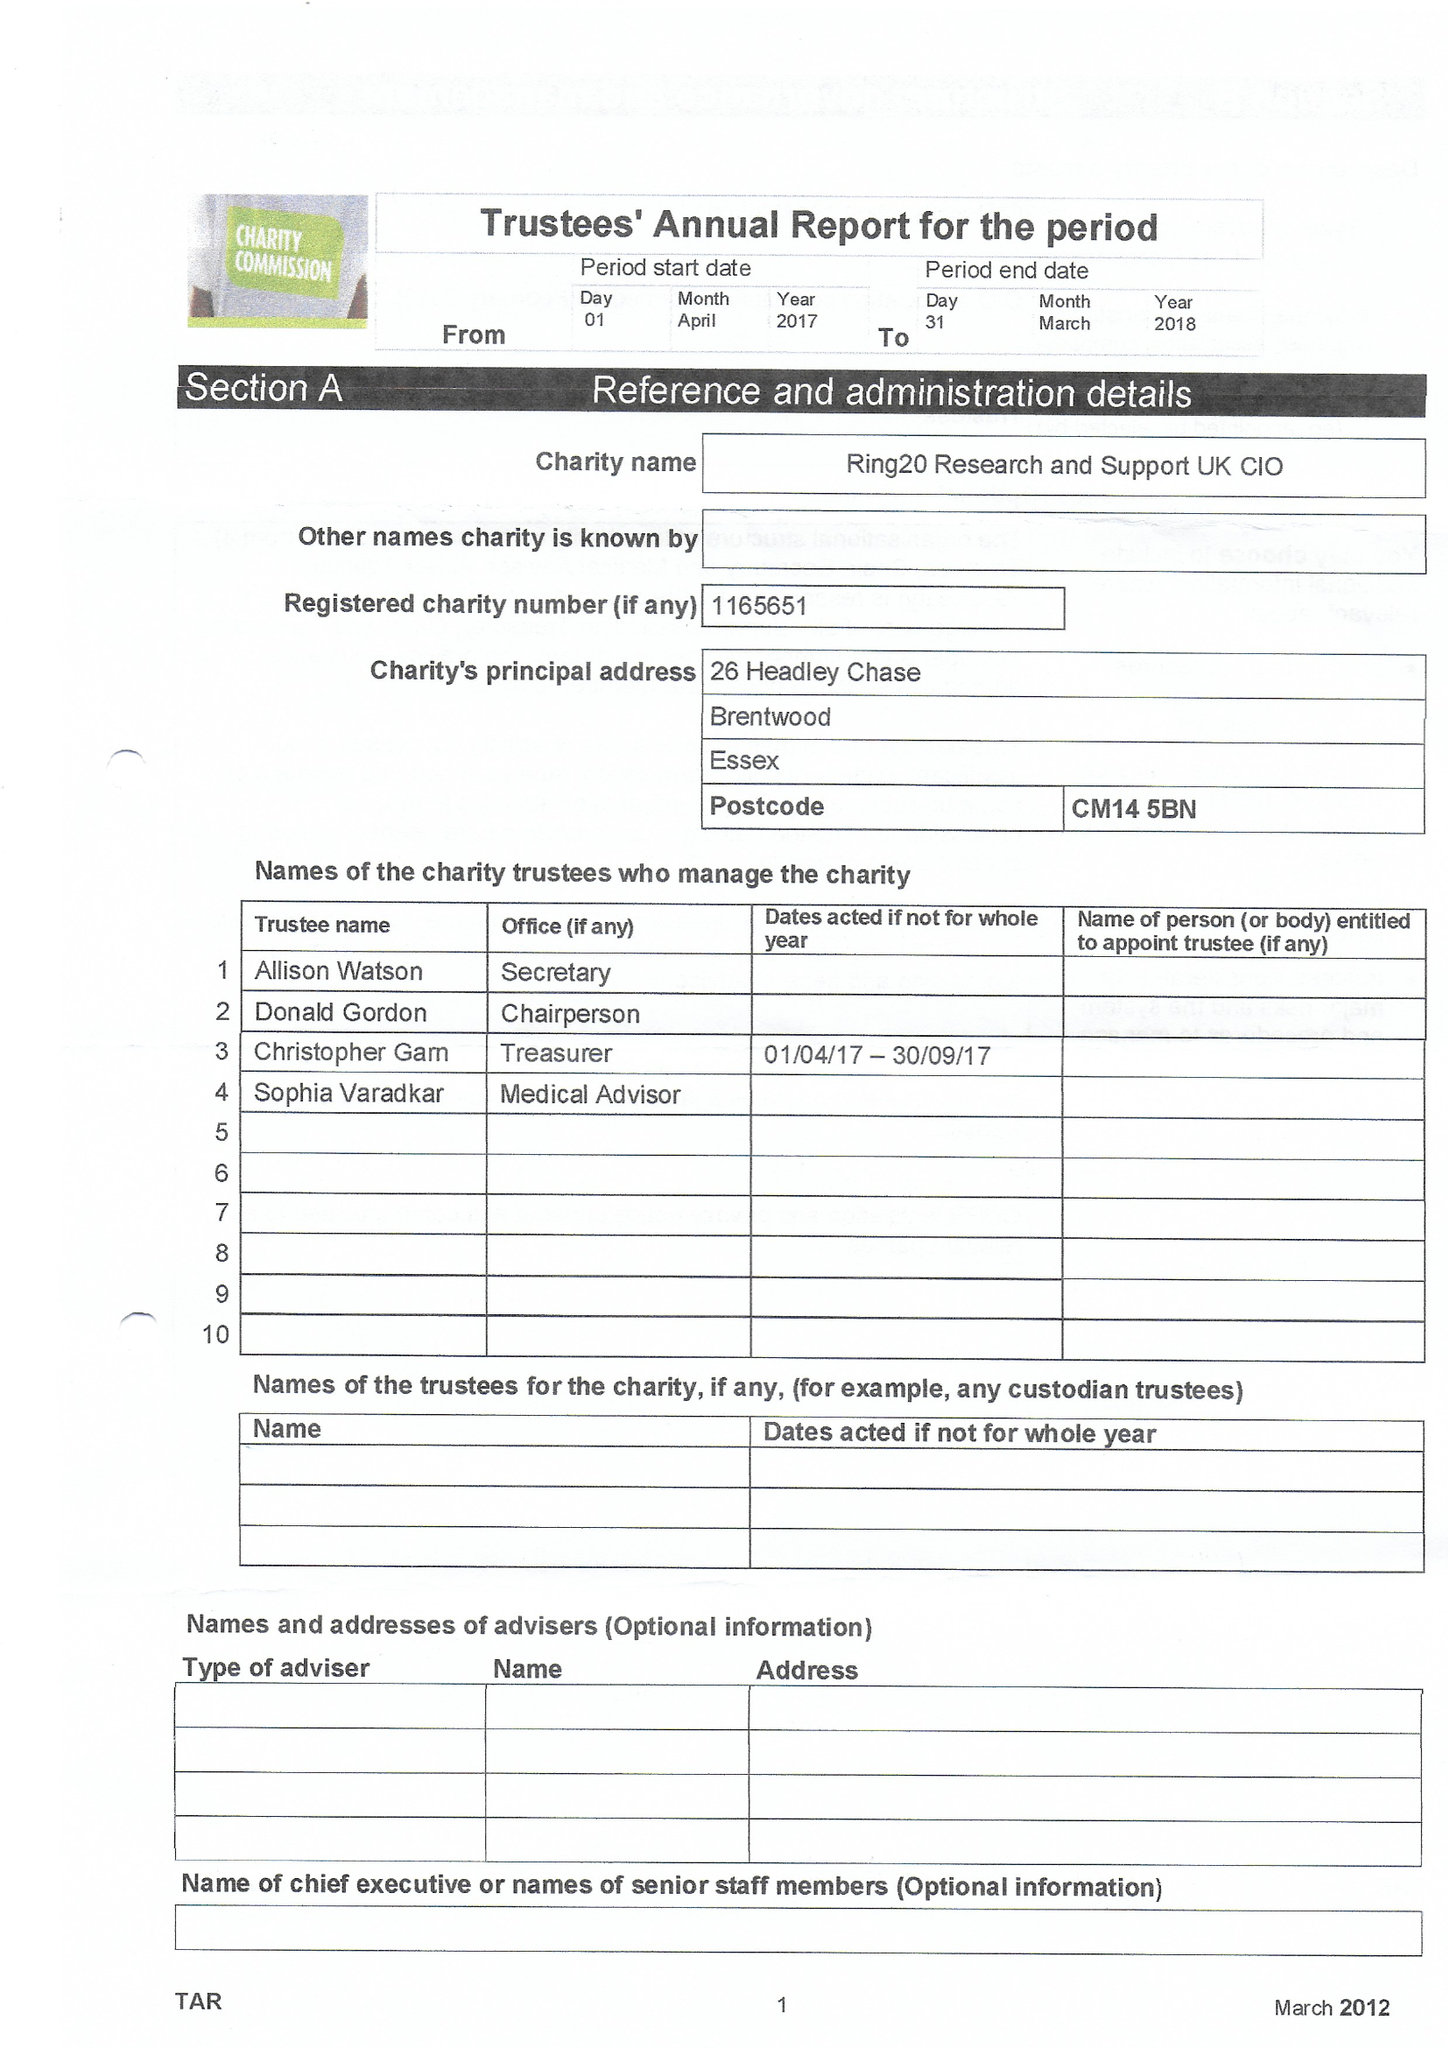What is the value for the spending_annually_in_british_pounds?
Answer the question using a single word or phrase. None 